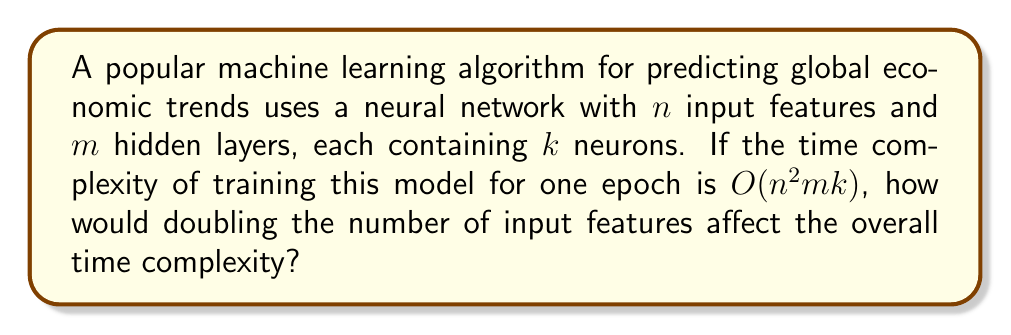Can you solve this math problem? To understand how doubling the number of input features affects the time complexity, let's break down the problem step-by-step:

1. Current time complexity: $O(n^2mk)$
   Where:
   - $n$ is the number of input features
   - $m$ is the number of hidden layers
   - $k$ is the number of neurons in each hidden layer

2. When we double the number of input features, $n$ becomes $2n$

3. Let's substitute $2n$ for $n$ in the original time complexity:

   $O((2n)^2mk)$

4. Simplify the expression:
   
   $O(4n^2mk)$

5. In Big O notation, we can remove constant factors. Therefore:

   $O(4n^2mk)$ simplifies to $O(n^2mk)$

6. Comparing the original and new time complexities:
   - Original: $O(n^2mk)$
   - New: $O(n^2mk)$

We can see that the time complexity remains the same in Big O notation, even after doubling the number of input features. This is because Big O notation describes the upper bound of the growth rate and ignores constant factors.

However, it's important to note that while the Big O complexity doesn't change, the actual running time would increase by a factor of 4 due to the squared term $n^2$.
Answer: The time complexity remains $O(n^2mk)$ after doubling the input features, but the actual running time increases by a factor of 4. 